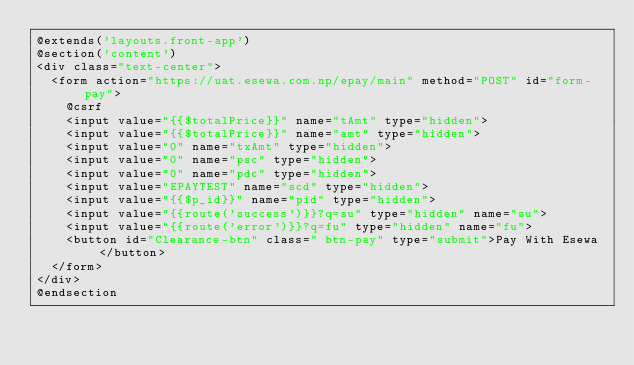Convert code to text. <code><loc_0><loc_0><loc_500><loc_500><_PHP_>@extends('layouts.front-app')
@section('content')
<div class="text-center">
	<form action="https://uat.esewa.com.np/epay/main" method="POST" id="form-pay">
		@csrf
		<input value="{{$totalPrice}}" name="tAmt" type="hidden">
		<input value="{{$totalPrice}}" name="amt" type="hidden">
		<input value="0" name="txAmt" type="hidden">
		<input value="0" name="psc" type="hidden">
		<input value="0" name="pdc" type="hidden">
		<input value="EPAYTEST" name="scd" type="hidden">
		<input value="{{$p_id}}" name="pid" type="hidden">
		<input value="{{route('success')}}?q=su" type="hidden" name="su">
		<input value="{{route('error')}}?q=fu" type="hidden" name="fu">
		<button id="Clearance-btn" class=" btn-pay" type="submit">Pay With Esewa</button>
	</form>
</div>
@endsection</code> 